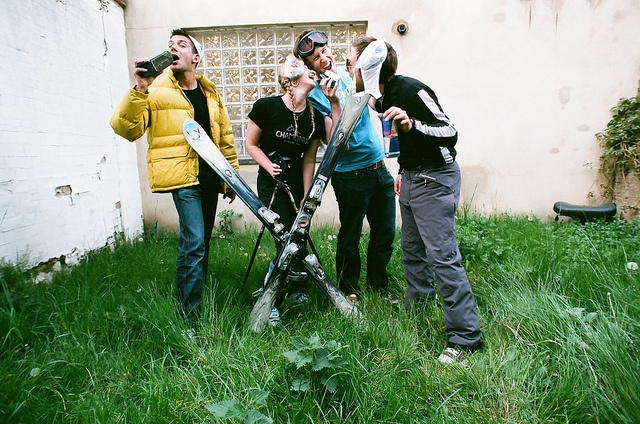Describe the objects in this image and their specific colors. I can see people in lightgray, black, gray, white, and purple tones, people in lightgray, black, and khaki tones, people in lightgray, black, darkgray, and teal tones, skis in lightgray, black, darkgray, and gray tones, and people in lightgray, black, lightpink, and gray tones in this image. 